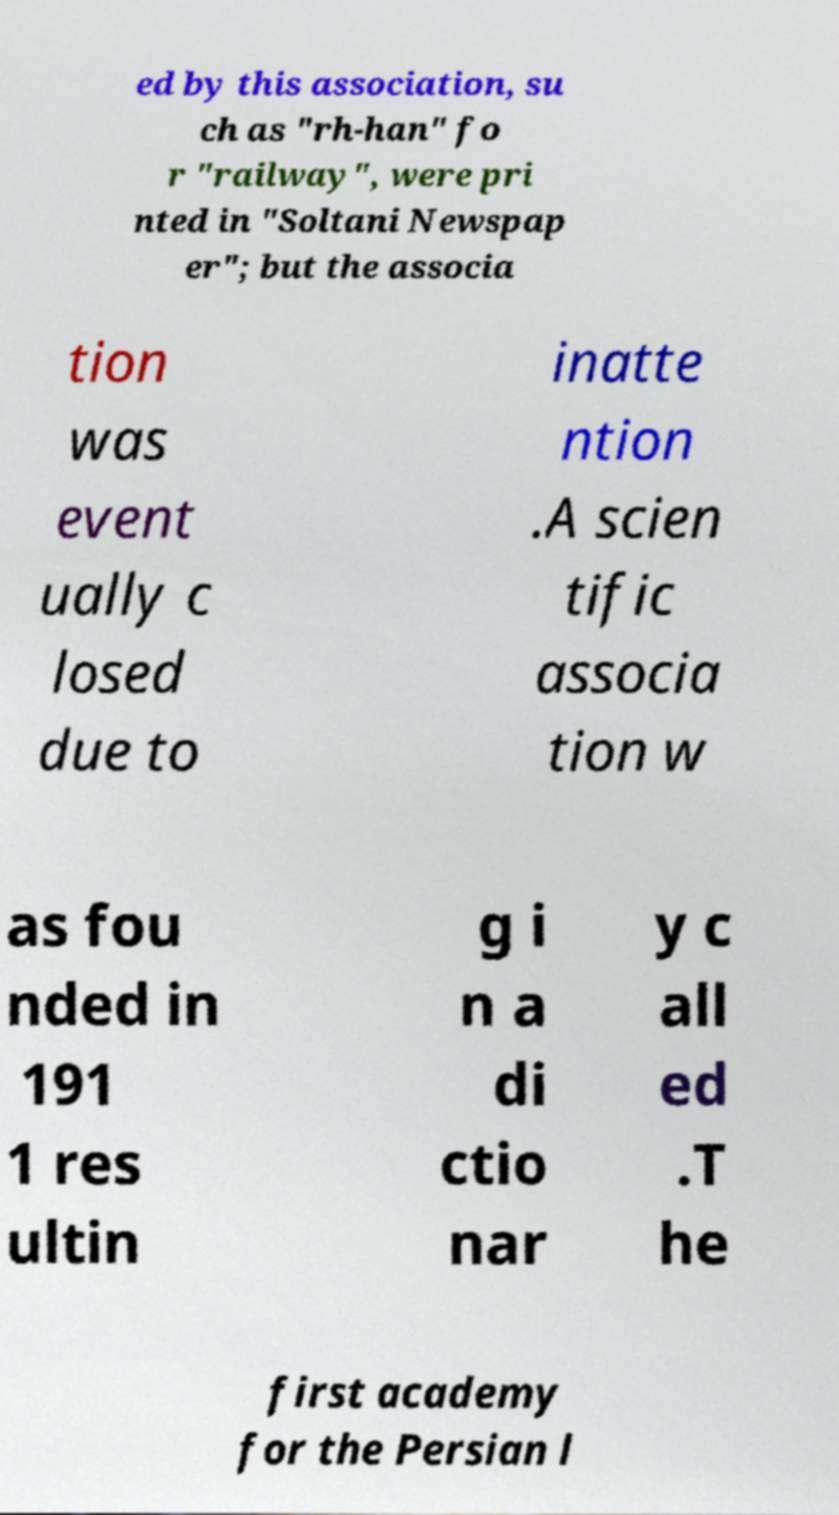Could you extract and type out the text from this image? ed by this association, su ch as "rh-han" fo r "railway", were pri nted in "Soltani Newspap er"; but the associa tion was event ually c losed due to inatte ntion .A scien tific associa tion w as fou nded in 191 1 res ultin g i n a di ctio nar y c all ed .T he first academy for the Persian l 